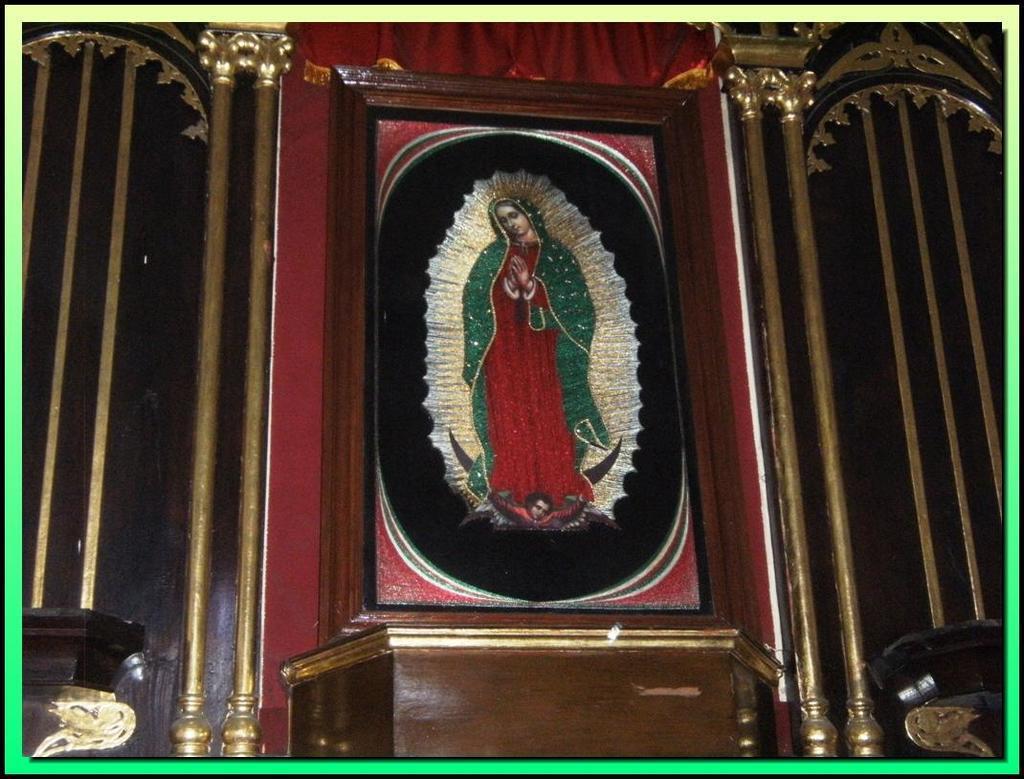Describe this image in one or two sentences. In the image there is a frame of a person. And the frame is on the wall. And also there are poles and designs on the wall. 